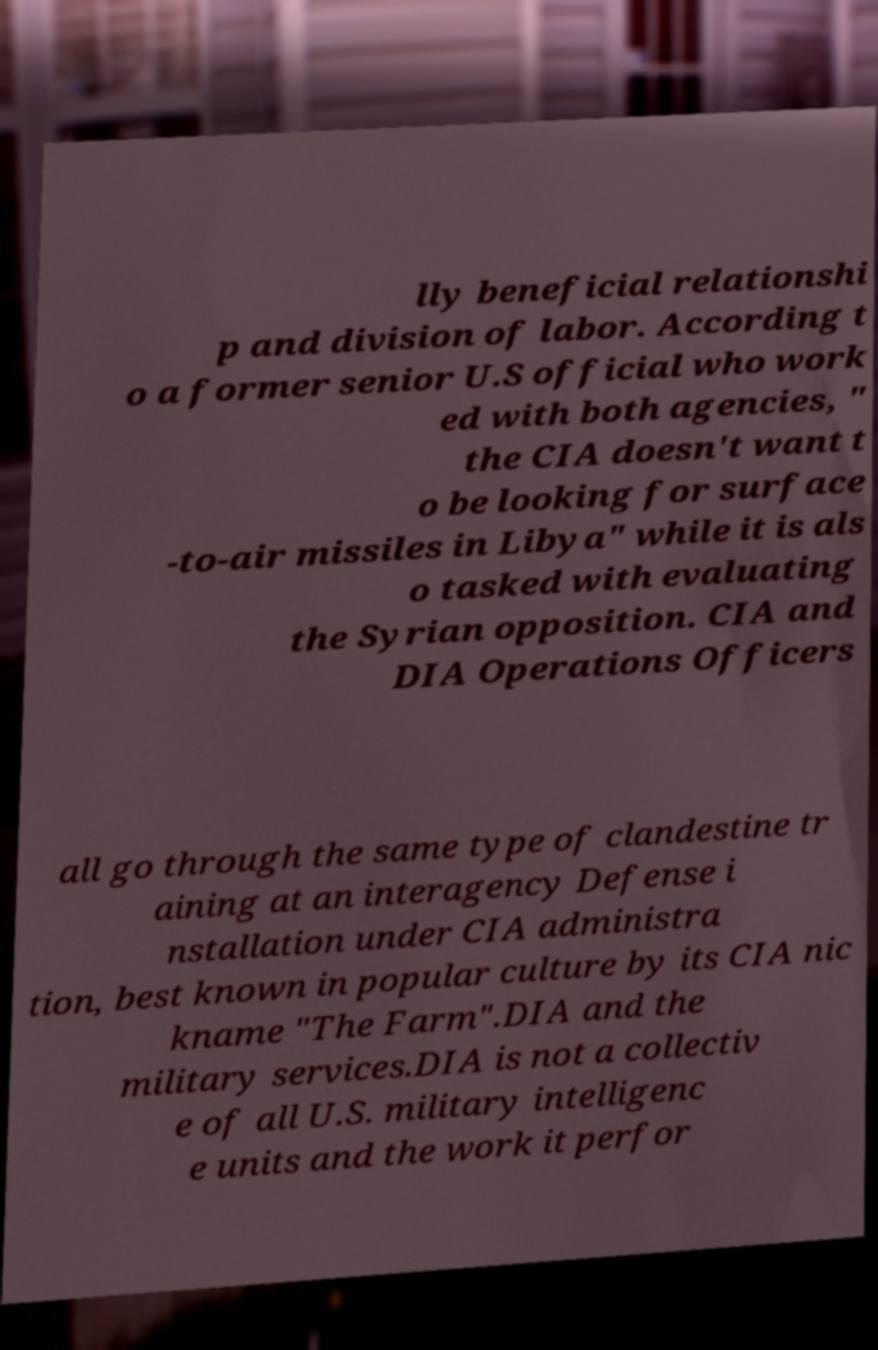Could you extract and type out the text from this image? lly beneficial relationshi p and division of labor. According t o a former senior U.S official who work ed with both agencies, " the CIA doesn't want t o be looking for surface -to-air missiles in Libya" while it is als o tasked with evaluating the Syrian opposition. CIA and DIA Operations Officers all go through the same type of clandestine tr aining at an interagency Defense i nstallation under CIA administra tion, best known in popular culture by its CIA nic kname "The Farm".DIA and the military services.DIA is not a collectiv e of all U.S. military intelligenc e units and the work it perfor 